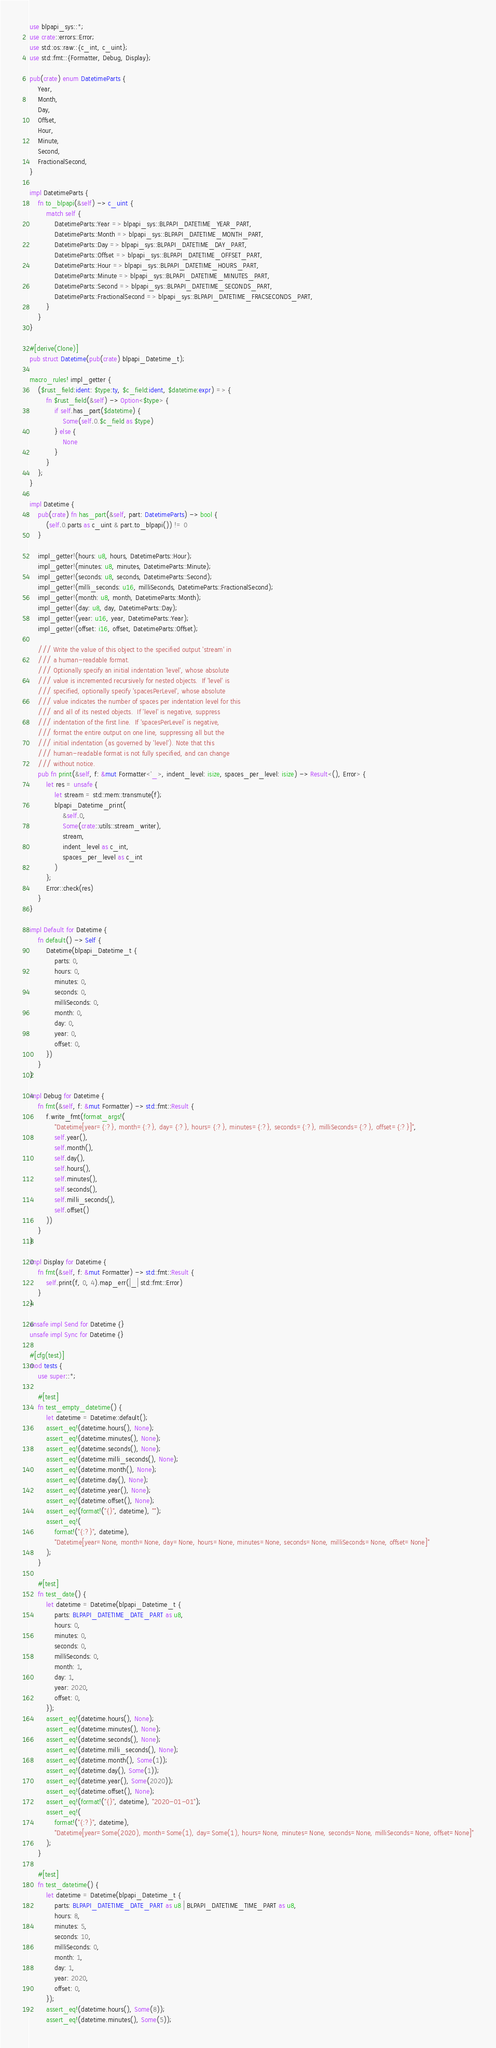<code> <loc_0><loc_0><loc_500><loc_500><_Rust_>use blpapi_sys::*;
use crate::errors::Error;
use std::os::raw::{c_int, c_uint};
use std::fmt::{Formatter, Debug, Display};

pub(crate) enum DatetimeParts {
    Year,
    Month,
    Day,
    Offset,
    Hour,
    Minute,
    Second,
    FractionalSecond,
}

impl DatetimeParts {
    fn to_blpapi(&self) -> c_uint {
        match self {
            DatetimeParts::Year => blpapi_sys::BLPAPI_DATETIME_YEAR_PART,
            DatetimeParts::Month => blpapi_sys::BLPAPI_DATETIME_MONTH_PART,
            DatetimeParts::Day => blpapi_sys::BLPAPI_DATETIME_DAY_PART,
            DatetimeParts::Offset => blpapi_sys::BLPAPI_DATETIME_OFFSET_PART,
            DatetimeParts::Hour => blpapi_sys::BLPAPI_DATETIME_HOURS_PART,
            DatetimeParts::Minute => blpapi_sys::BLPAPI_DATETIME_MINUTES_PART,
            DatetimeParts::Second => blpapi_sys::BLPAPI_DATETIME_SECONDS_PART,
            DatetimeParts::FractionalSecond => blpapi_sys::BLPAPI_DATETIME_FRACSECONDS_PART,
        }
    }
}

#[derive(Clone)]
pub struct Datetime(pub(crate) blpapi_Datetime_t);

macro_rules! impl_getter {
    ($rust_field:ident: $type:ty, $c_field:ident, $datetime:expr) => {
        fn $rust_field(&self) -> Option<$type> {
            if self.has_part($datetime) {
                Some(self.0.$c_field as $type)
            } else {
                None
            }
        }
    };
}

impl Datetime {
    pub(crate) fn has_part(&self, part: DatetimeParts) -> bool {
        (self.0.parts as c_uint & part.to_blpapi()) != 0
    }

    impl_getter!(hours: u8, hours, DatetimeParts::Hour);
    impl_getter!(minutes: u8, minutes, DatetimeParts::Minute);
    impl_getter!(seconds: u8, seconds, DatetimeParts::Second);
    impl_getter!(milli_seconds: u16, milliSeconds, DatetimeParts::FractionalSecond);
    impl_getter!(month: u8, month, DatetimeParts::Month);
    impl_getter!(day: u8, day, DatetimeParts::Day);
    impl_getter!(year: u16, year, DatetimeParts::Year);
    impl_getter!(offset: i16, offset, DatetimeParts::Offset);

    /// Write the value of this object to the specified output 'stream' in
    /// a human-readable format.
    /// Optionally specify an initial indentation 'level', whose absolute
    /// value is incremented recursively for nested objects.  If 'level' is
    /// specified, optionally specify 'spacesPerLevel', whose absolute
    /// value indicates the number of spaces per indentation level for this
    /// and all of its nested objects.  If 'level' is negative, suppress
    /// indentation of the first line.  If 'spacesPerLevel' is negative,
    /// format the entire output on one line, suppressing all but the
    /// initial indentation (as governed by 'level'). Note that this
    /// human-readable format is not fully specified, and can change
    /// without notice.
    pub fn print(&self, f: &mut Formatter<'_>, indent_level: isize, spaces_per_level: isize) -> Result<(), Error> {
        let res = unsafe {
            let stream = std::mem::transmute(f);
            blpapi_Datetime_print(
                &self.0,
                Some(crate::utils::stream_writer),
                stream,
                indent_level as c_int,
                spaces_per_level as c_int
            )
        };
        Error::check(res)
    }
}

impl Default for Datetime {
    fn default() -> Self {
        Datetime(blpapi_Datetime_t {
            parts: 0,
            hours: 0,
            minutes: 0,
            seconds: 0,
            milliSeconds: 0,
            month: 0,
            day: 0,
            year: 0,
            offset: 0,
        })
    }
}

impl Debug for Datetime {
    fn fmt(&self, f: &mut Formatter) -> std::fmt::Result {
        f.write_fmt(format_args!(
            "Datetime[year={:?}, month={:?}, day={:?}, hours={:?}, minutes={:?}, seconds={:?}, milliSeconds={:?}, offset={:?}]",
            self.year(),
            self.month(),
            self.day(),
            self.hours(),
            self.minutes(),
            self.seconds(),
            self.milli_seconds(),
            self.offset()
        ))
    }
}

impl Display for Datetime {
    fn fmt(&self, f: &mut Formatter) -> std::fmt::Result {
        self.print(f, 0, 4).map_err(|_| std::fmt::Error)
    }
}

unsafe impl Send for Datetime {}
unsafe impl Sync for Datetime {}

#[cfg(test)]
mod tests {
    use super::*;

    #[test]
    fn test_empty_datetime() {
        let datetime = Datetime::default();
        assert_eq!(datetime.hours(), None);
        assert_eq!(datetime.minutes(), None);
        assert_eq!(datetime.seconds(), None);
        assert_eq!(datetime.milli_seconds(), None);
        assert_eq!(datetime.month(), None);
        assert_eq!(datetime.day(), None);
        assert_eq!(datetime.year(), None);
        assert_eq!(datetime.offset(), None);
        assert_eq!(format!("{}", datetime), "");
        assert_eq!(
            format!("{:?}", datetime),
            "Datetime[year=None, month=None, day=None, hours=None, minutes=None, seconds=None, milliSeconds=None, offset=None]"
        );
    }

    #[test]
    fn test_date() {
        let datetime = Datetime(blpapi_Datetime_t {
            parts: BLPAPI_DATETIME_DATE_PART as u8,
            hours: 0,
            minutes: 0,
            seconds: 0,
            milliSeconds: 0,
            month: 1,
            day: 1,
            year: 2020,
            offset: 0,
        });
        assert_eq!(datetime.hours(), None);
        assert_eq!(datetime.minutes(), None);
        assert_eq!(datetime.seconds(), None);
        assert_eq!(datetime.milli_seconds(), None);
        assert_eq!(datetime.month(), Some(1));
        assert_eq!(datetime.day(), Some(1));
        assert_eq!(datetime.year(), Some(2020));
        assert_eq!(datetime.offset(), None);
        assert_eq!(format!("{}", datetime), "2020-01-01");
        assert_eq!(
            format!("{:?}", datetime),
            "Datetime[year=Some(2020), month=Some(1), day=Some(1), hours=None, minutes=None, seconds=None, milliSeconds=None, offset=None]"
        );
    }

    #[test]
    fn test_datetime() {
        let datetime = Datetime(blpapi_Datetime_t {
            parts: BLPAPI_DATETIME_DATE_PART as u8 | BLPAPI_DATETIME_TIME_PART as u8,
            hours: 8,
            minutes: 5,
            seconds: 10,
            milliSeconds: 0,
            month: 1,
            day: 1,
            year: 2020,
            offset: 0,
        });
        assert_eq!(datetime.hours(), Some(8));
        assert_eq!(datetime.minutes(), Some(5));</code> 